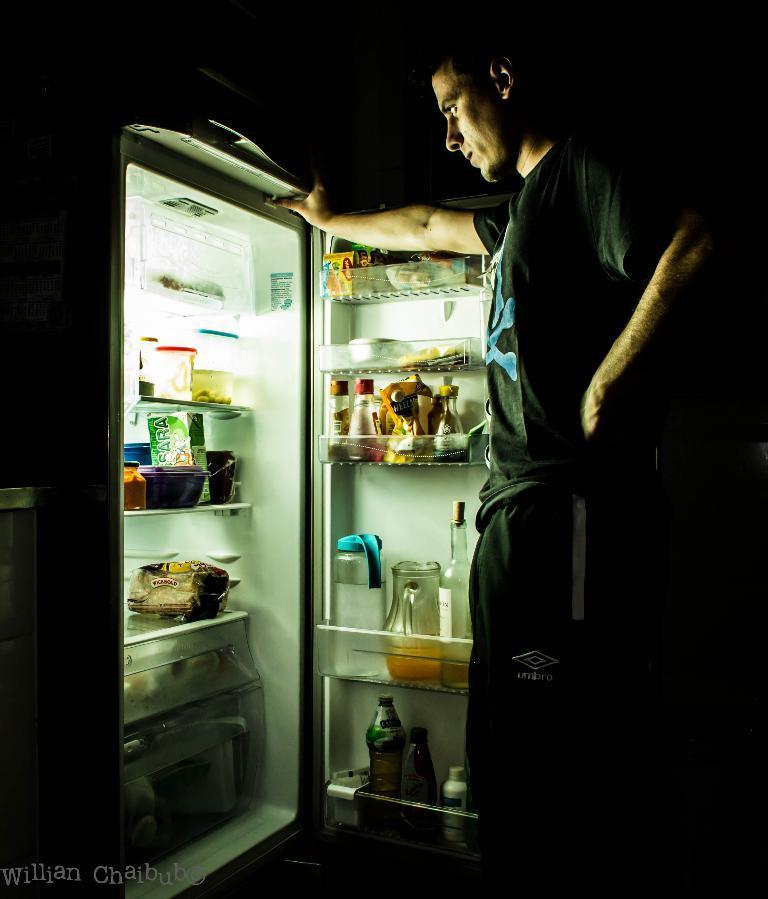Could you give a brief overview of what you see in this image? This is an image clicked in the dark. On the left side, I can see a refrigerator and its door is opened. Inside the refrigerator I can see bowls, packers and some more objects. To the door there are some bottles, packets and some objects are placed. In front of this refrigerator I can see a man wearing black color t-shirt, standing by looking at the refrigerator. 